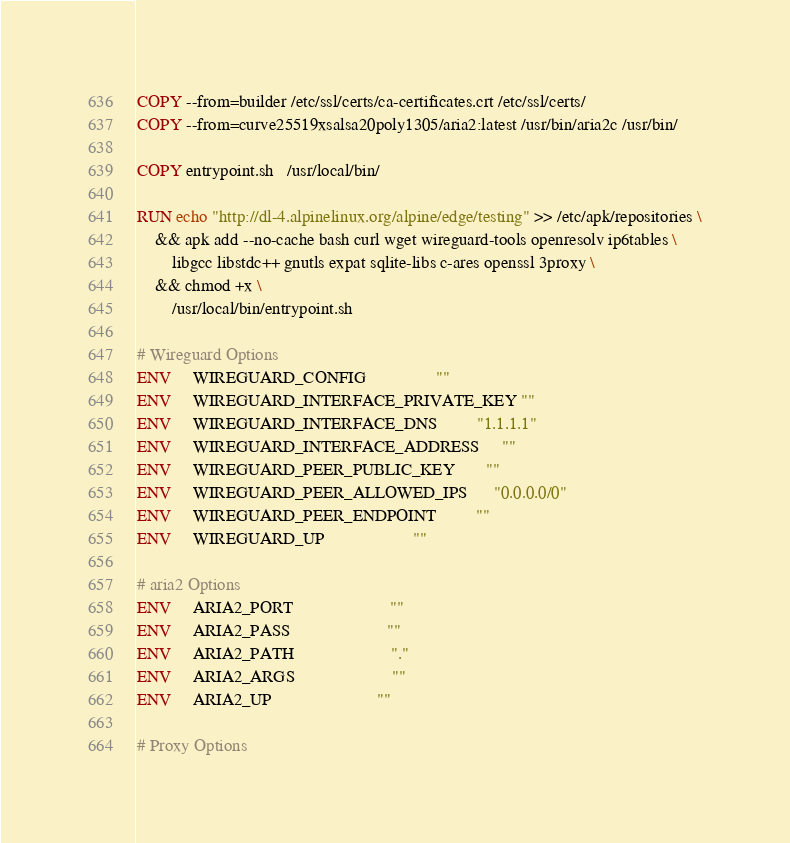Convert code to text. <code><loc_0><loc_0><loc_500><loc_500><_Dockerfile_>COPY --from=builder /etc/ssl/certs/ca-certificates.crt /etc/ssl/certs/
COPY --from=curve25519xsalsa20poly1305/aria2:latest /usr/bin/aria2c /usr/bin/

COPY entrypoint.sh   /usr/local/bin/

RUN echo "http://dl-4.alpinelinux.org/alpine/edge/testing" >> /etc/apk/repositories \
    && apk add --no-cache bash curl wget wireguard-tools openresolv ip6tables \
        libgcc libstdc++ gnutls expat sqlite-libs c-ares openssl 3proxy \
    && chmod +x \
        /usr/local/bin/entrypoint.sh

# Wireguard Options
ENV     WIREGUARD_CONFIG                ""
ENV     WIREGUARD_INTERFACE_PRIVATE_KEY ""
ENV     WIREGUARD_INTERFACE_DNS         "1.1.1.1"
ENV     WIREGUARD_INTERFACE_ADDRESS     ""
ENV     WIREGUARD_PEER_PUBLIC_KEY       ""
ENV     WIREGUARD_PEER_ALLOWED_IPS      "0.0.0.0/0"
ENV     WIREGUARD_PEER_ENDPOINT         ""
ENV     WIREGUARD_UP                    ""

# aria2 Options
ENV     ARIA2_PORT                      ""
ENV     ARIA2_PASS                      ""
ENV     ARIA2_PATH                      "."
ENV     ARIA2_ARGS                      ""
ENV     ARIA2_UP                        ""

# Proxy Options</code> 